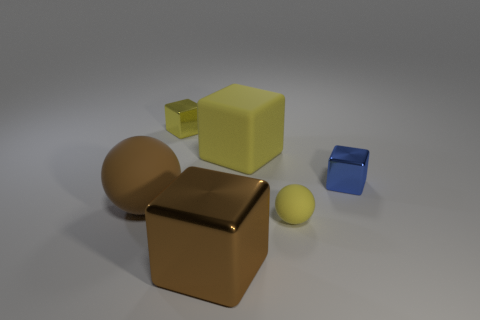Add 2 brown things. How many objects exist? 8 Subtract all cubes. How many objects are left? 2 Add 5 small purple metal blocks. How many small purple metal blocks exist? 5 Subtract 0 purple cubes. How many objects are left? 6 Subtract all big cyan cylinders. Subtract all big brown rubber spheres. How many objects are left? 5 Add 2 metallic things. How many metallic things are left? 5 